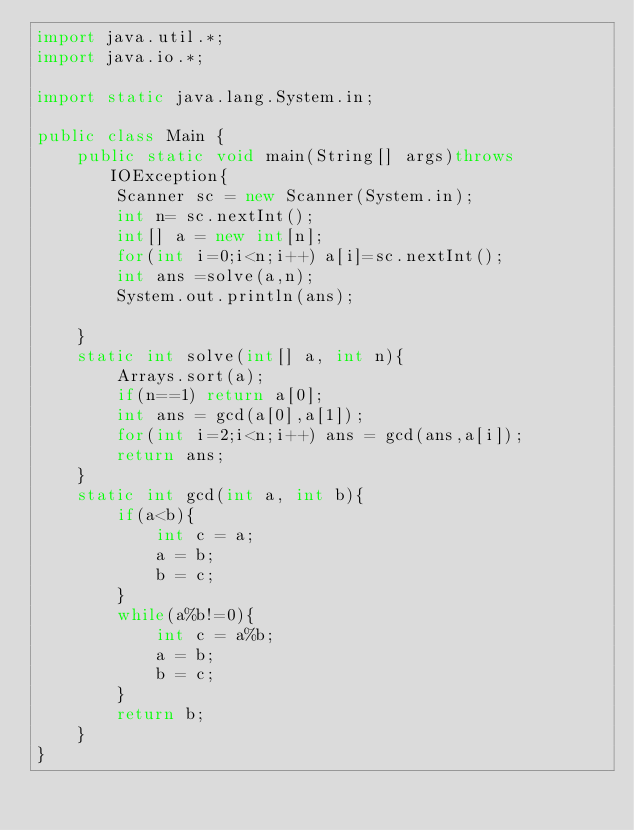Convert code to text. <code><loc_0><loc_0><loc_500><loc_500><_Java_>import java.util.*;
import java.io.*;

import static java.lang.System.in;

public class Main {
    public static void main(String[] args)throws IOException{
        Scanner sc = new Scanner(System.in);
        int n= sc.nextInt();
        int[] a = new int[n];
        for(int i=0;i<n;i++) a[i]=sc.nextInt();
        int ans =solve(a,n);
        System.out.println(ans);

    }
    static int solve(int[] a, int n){
        Arrays.sort(a);
        if(n==1) return a[0];
        int ans = gcd(a[0],a[1]);
        for(int i=2;i<n;i++) ans = gcd(ans,a[i]);
        return ans;
    }
    static int gcd(int a, int b){
        if(a<b){
            int c = a;
            a = b;
            b = c;
        }
        while(a%b!=0){
            int c = a%b;
            a = b;
            b = c;
        }
        return b;
    }
}
</code> 